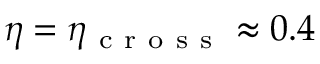<formula> <loc_0><loc_0><loc_500><loc_500>\eta = \eta _ { c r o s s } \approx 0 . 4</formula> 